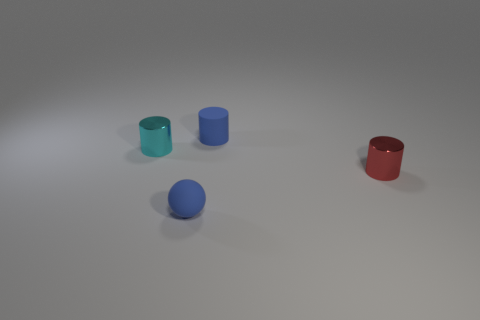Subtract all small red metal cylinders. How many cylinders are left? 2 Subtract all red cylinders. How many cylinders are left? 2 Subtract 2 cylinders. How many cylinders are left? 1 Add 2 yellow things. How many objects exist? 6 Subtract all brown balls. Subtract all purple cylinders. How many balls are left? 1 Subtract 0 red cubes. How many objects are left? 4 Subtract all cylinders. How many objects are left? 1 Subtract all yellow balls. How many brown cylinders are left? 0 Subtract all large green cubes. Subtract all tiny objects. How many objects are left? 0 Add 3 blue balls. How many blue balls are left? 4 